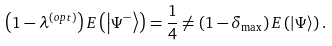<formula> <loc_0><loc_0><loc_500><loc_500>\left ( 1 - \lambda ^ { \left ( o p t \right ) } \right ) E \left ( \left | \Psi ^ { - } \right \rangle \right ) = \frac { 1 } { 4 } \neq \left ( 1 - \delta _ { \max } \right ) E \left ( \left | \Psi \right \rangle \right ) .</formula> 